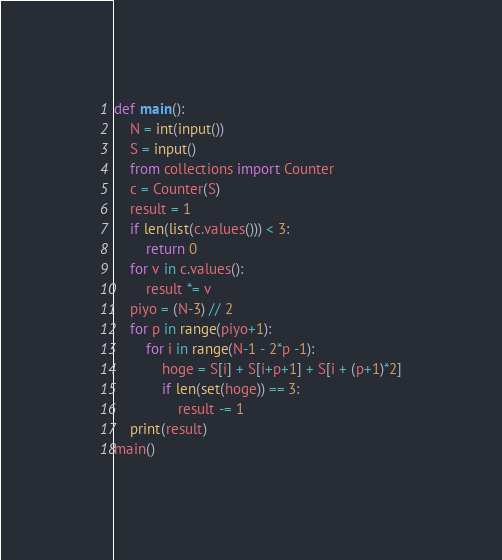<code> <loc_0><loc_0><loc_500><loc_500><_Python_>def main():
    N = int(input())
    S = input()
    from collections import Counter
    c = Counter(S)
    result = 1
    if len(list(c.values())) < 3:
        return 0
    for v in c.values():
        result *= v
    piyo = (N-3) // 2
    for p in range(piyo+1):
        for i in range(N-1 - 2*p -1):
            hoge = S[i] + S[i+p+1] + S[i + (p+1)*2]
            if len(set(hoge)) == 3:
                result -= 1
    print(result)
main()</code> 